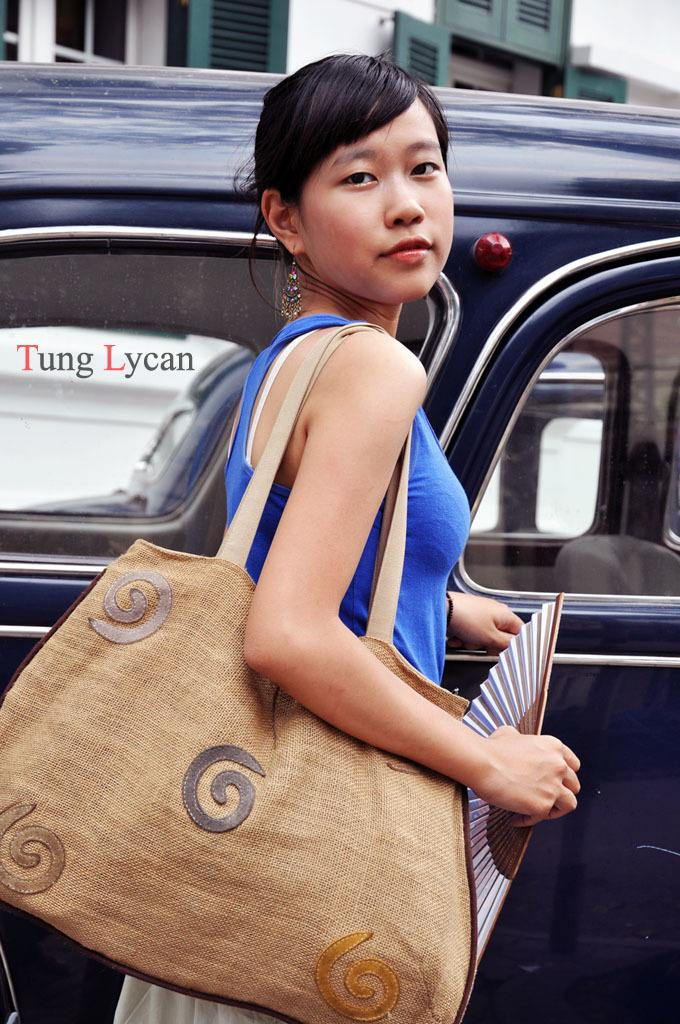What is the main subject of the image? There is a woman standing in the image. What is the woman wearing? The woman is wearing a bag. What can be seen in the background of the image? There is a car and a window in the background of the image. What type of rock can be seen in the woman's hand in the image? There is no rock visible in the woman's hand in the image. How many zebras are present in the background of the image? There are no zebras present in the image; only a car and a window can be seen in the background. 